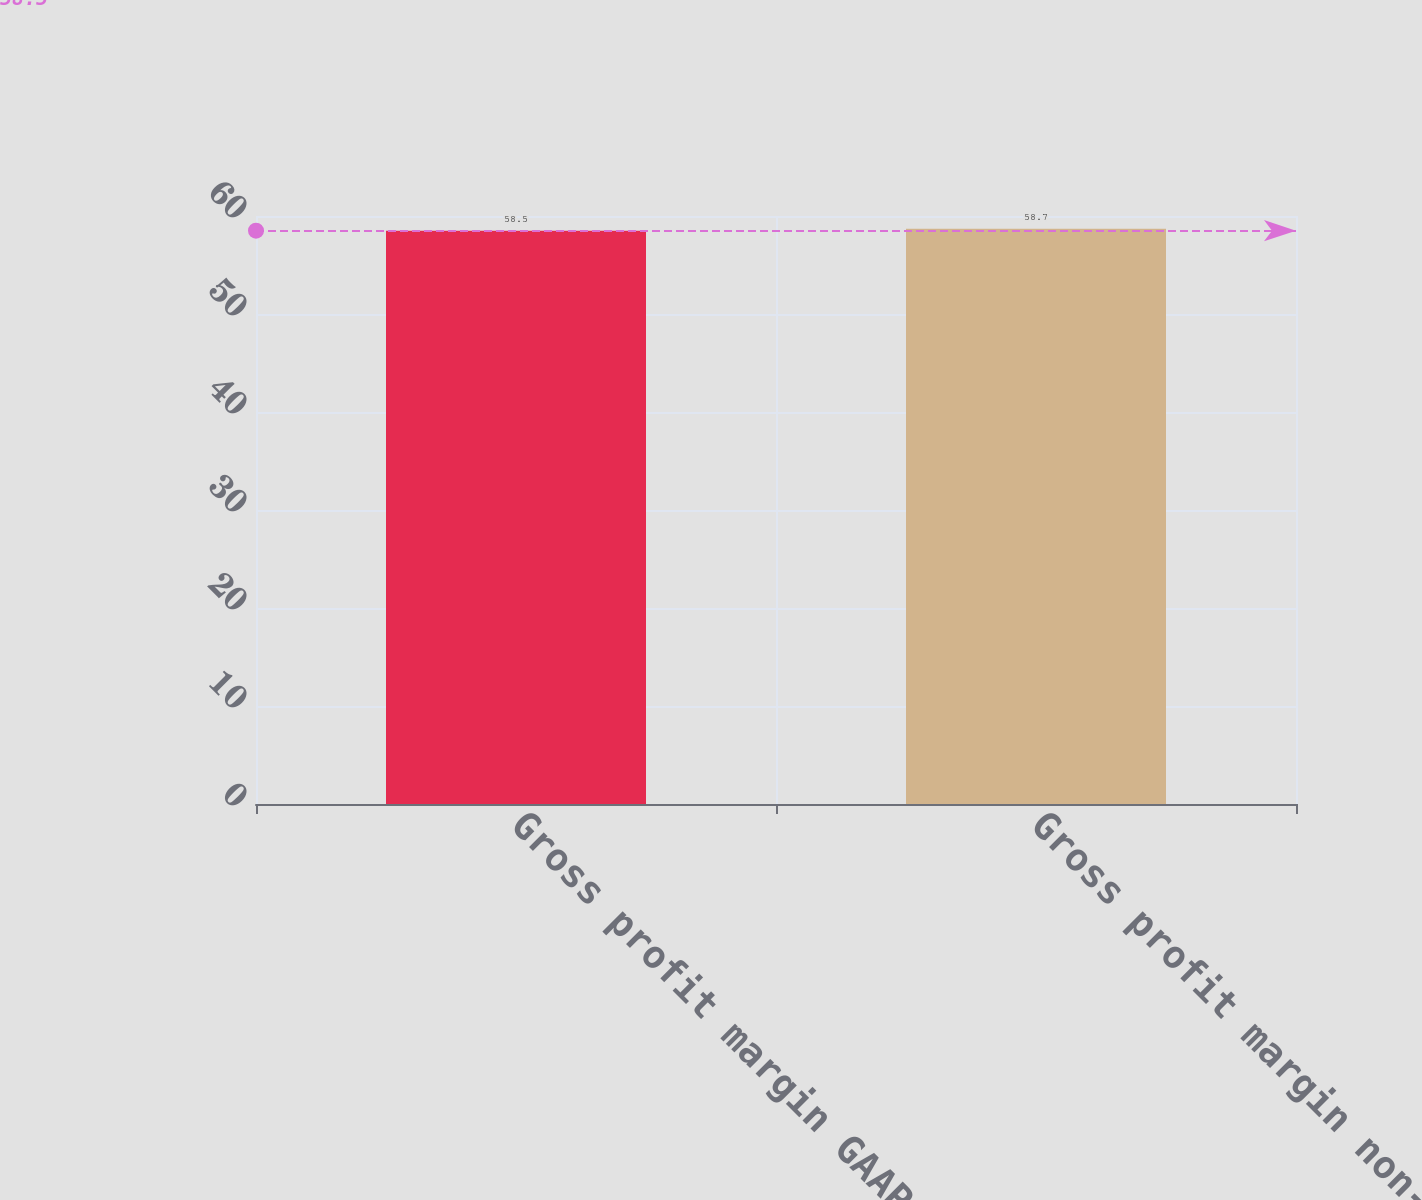Convert chart to OTSL. <chart><loc_0><loc_0><loc_500><loc_500><bar_chart><fcel>Gross profit margin GAAP<fcel>Gross profit margin non-GAAP<nl><fcel>58.5<fcel>58.7<nl></chart> 